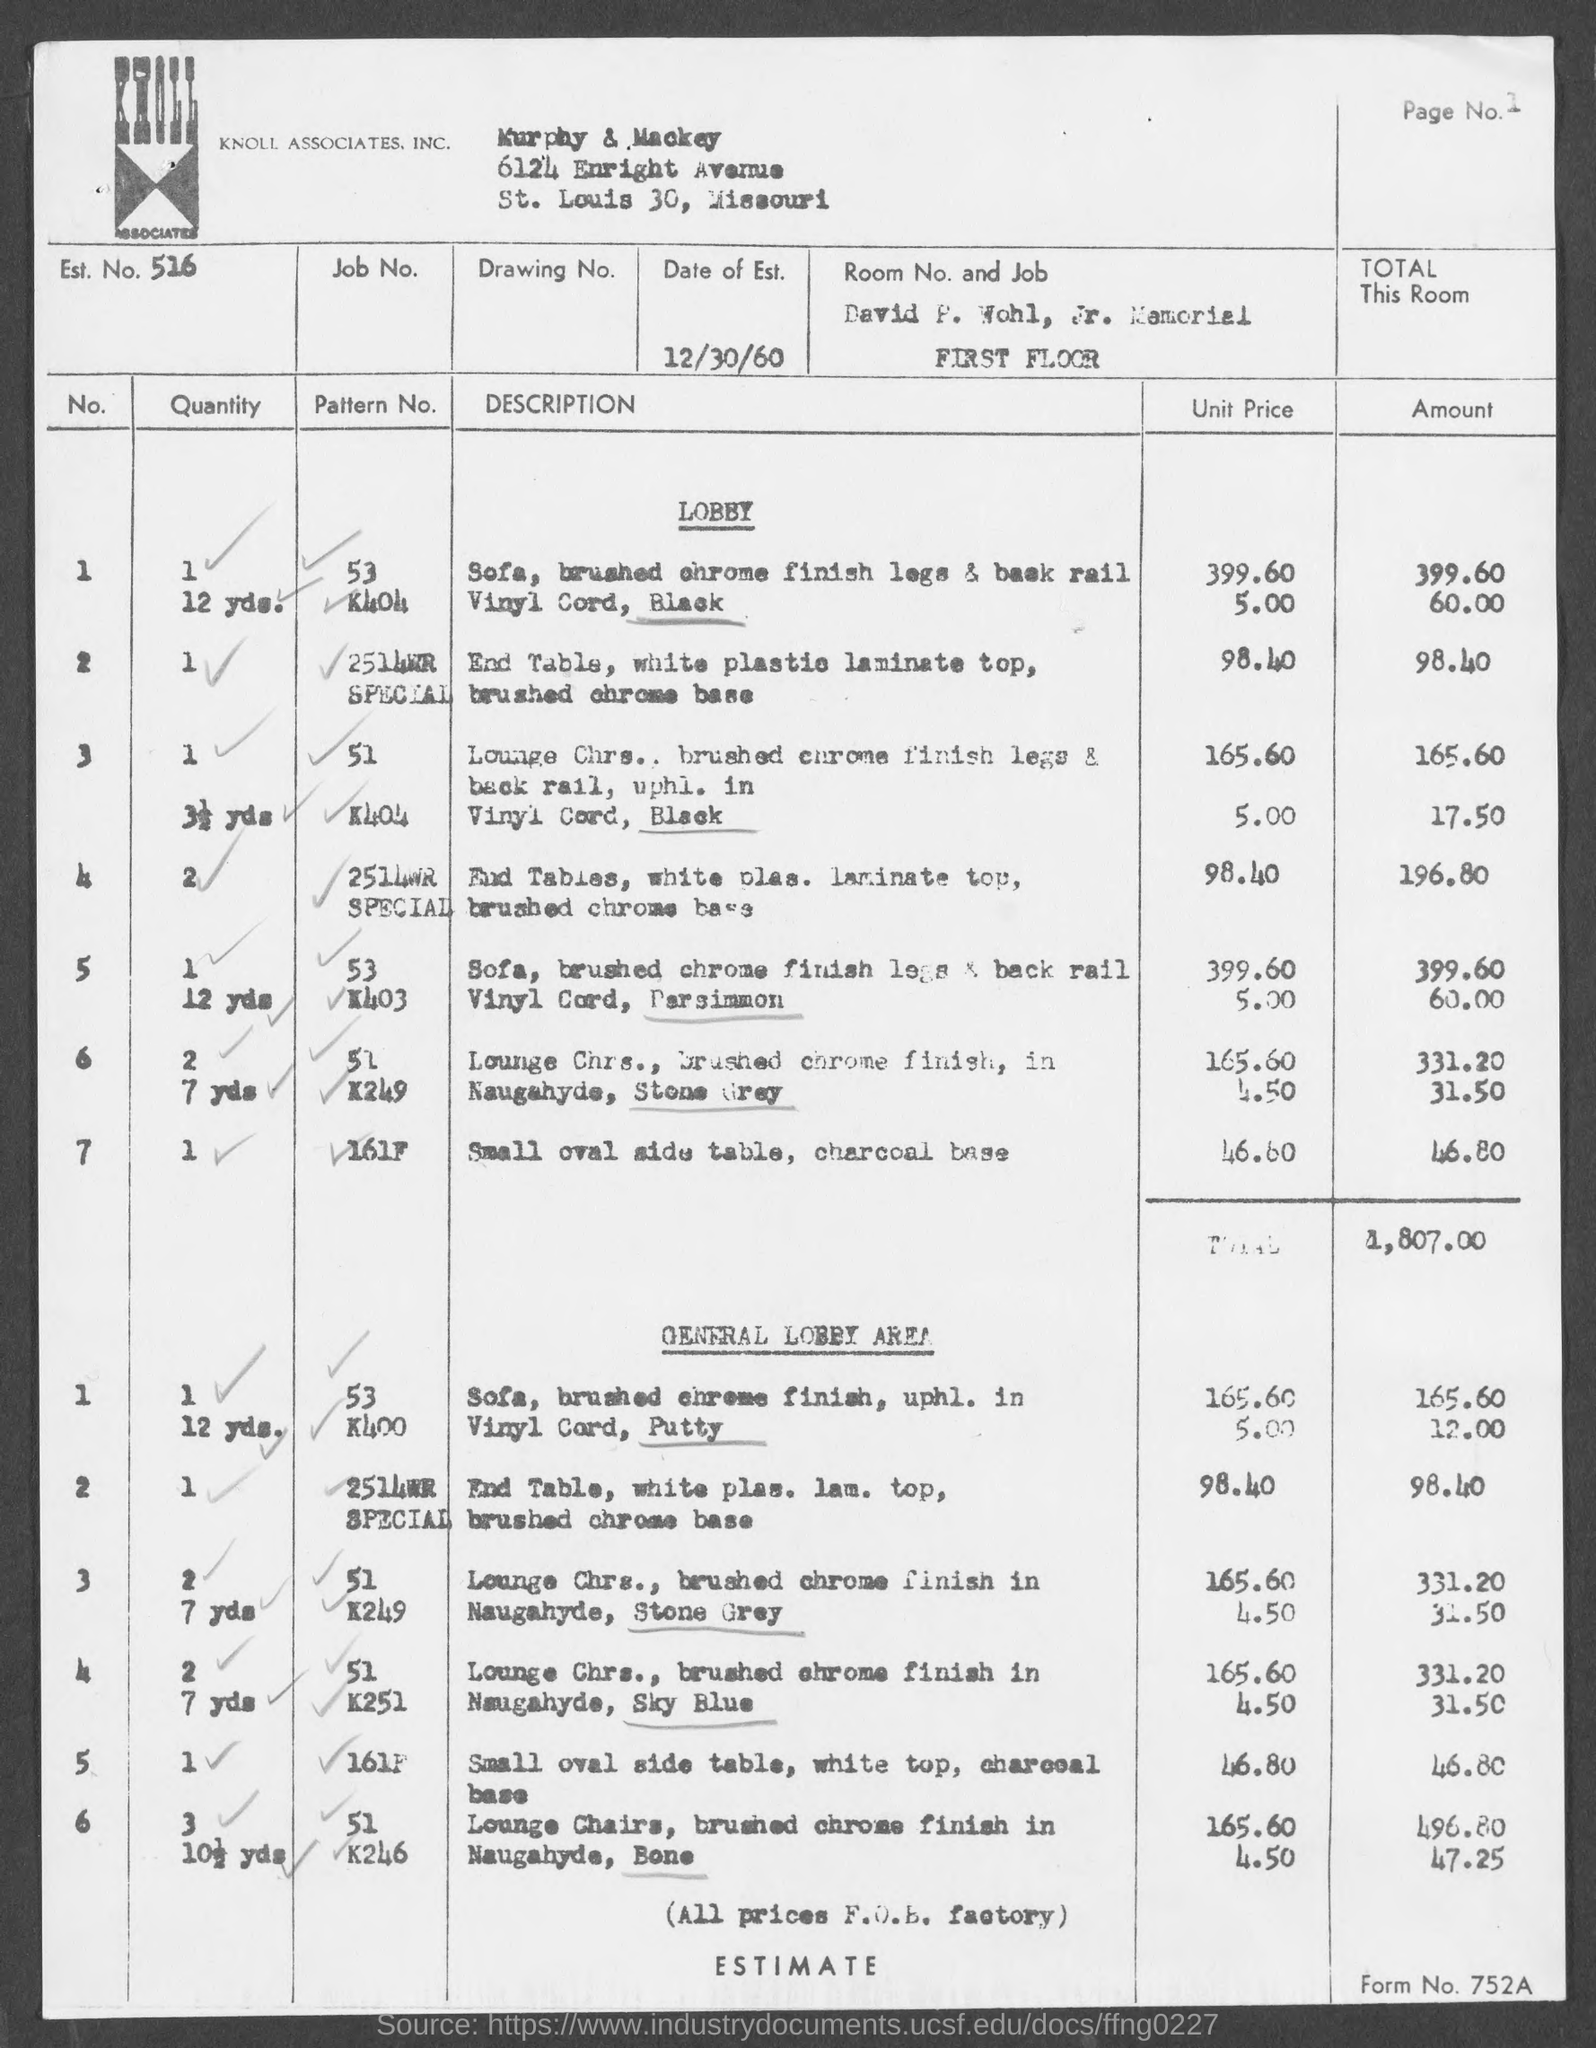What is the page no. at top-right corner of the page ?
Keep it short and to the point. 1. What is the est. no.?
Your answer should be compact. 516. In which state is murphy & mackey at ?
Provide a succinct answer. Missouri. What is the form no.?
Ensure brevity in your answer.  752A. 